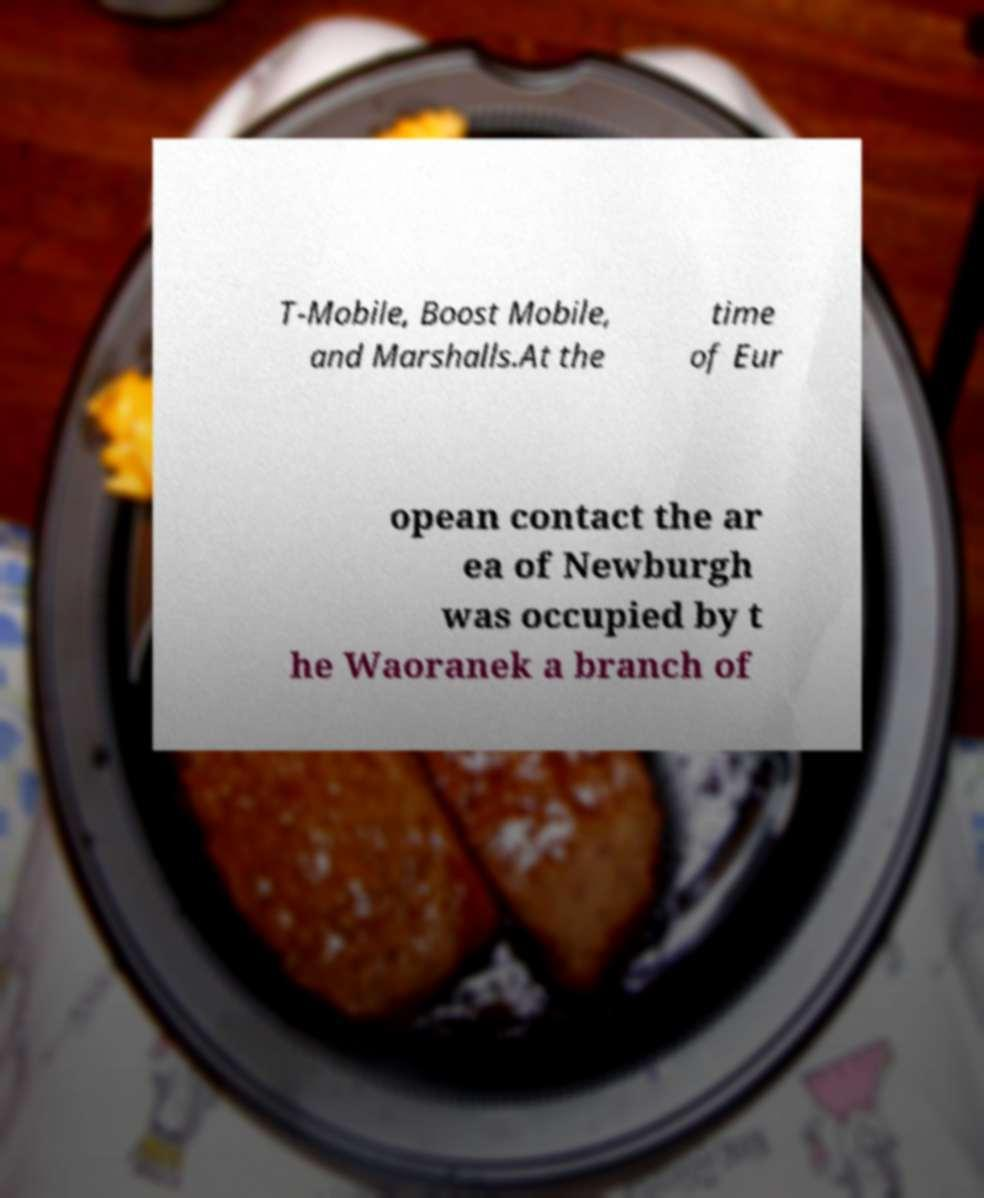There's text embedded in this image that I need extracted. Can you transcribe it verbatim? T-Mobile, Boost Mobile, and Marshalls.At the time of Eur opean contact the ar ea of Newburgh was occupied by t he Waoranek a branch of 